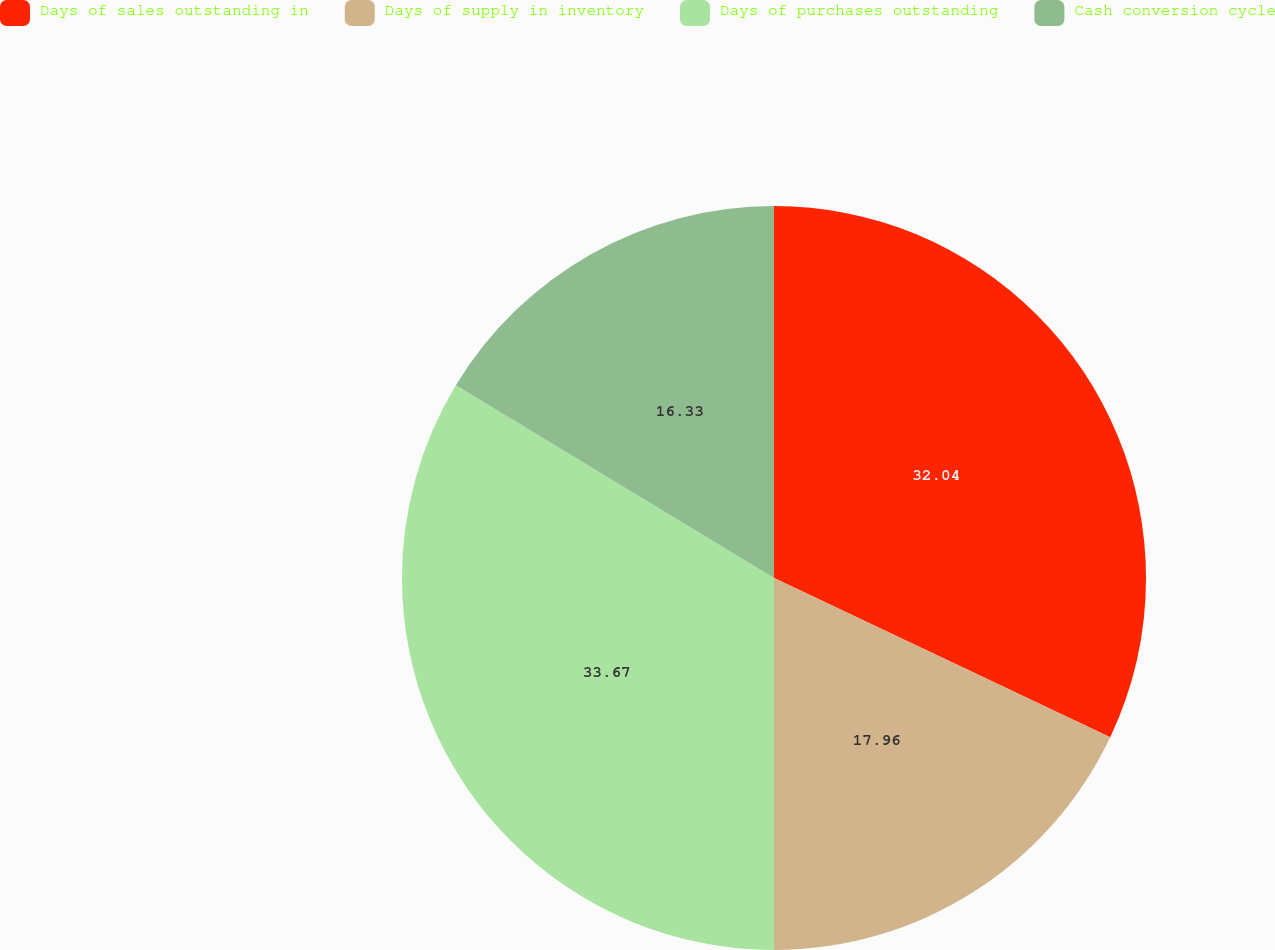Convert chart. <chart><loc_0><loc_0><loc_500><loc_500><pie_chart><fcel>Days of sales outstanding in<fcel>Days of supply in inventory<fcel>Days of purchases outstanding<fcel>Cash conversion cycle<nl><fcel>32.04%<fcel>17.96%<fcel>33.67%<fcel>16.33%<nl></chart> 